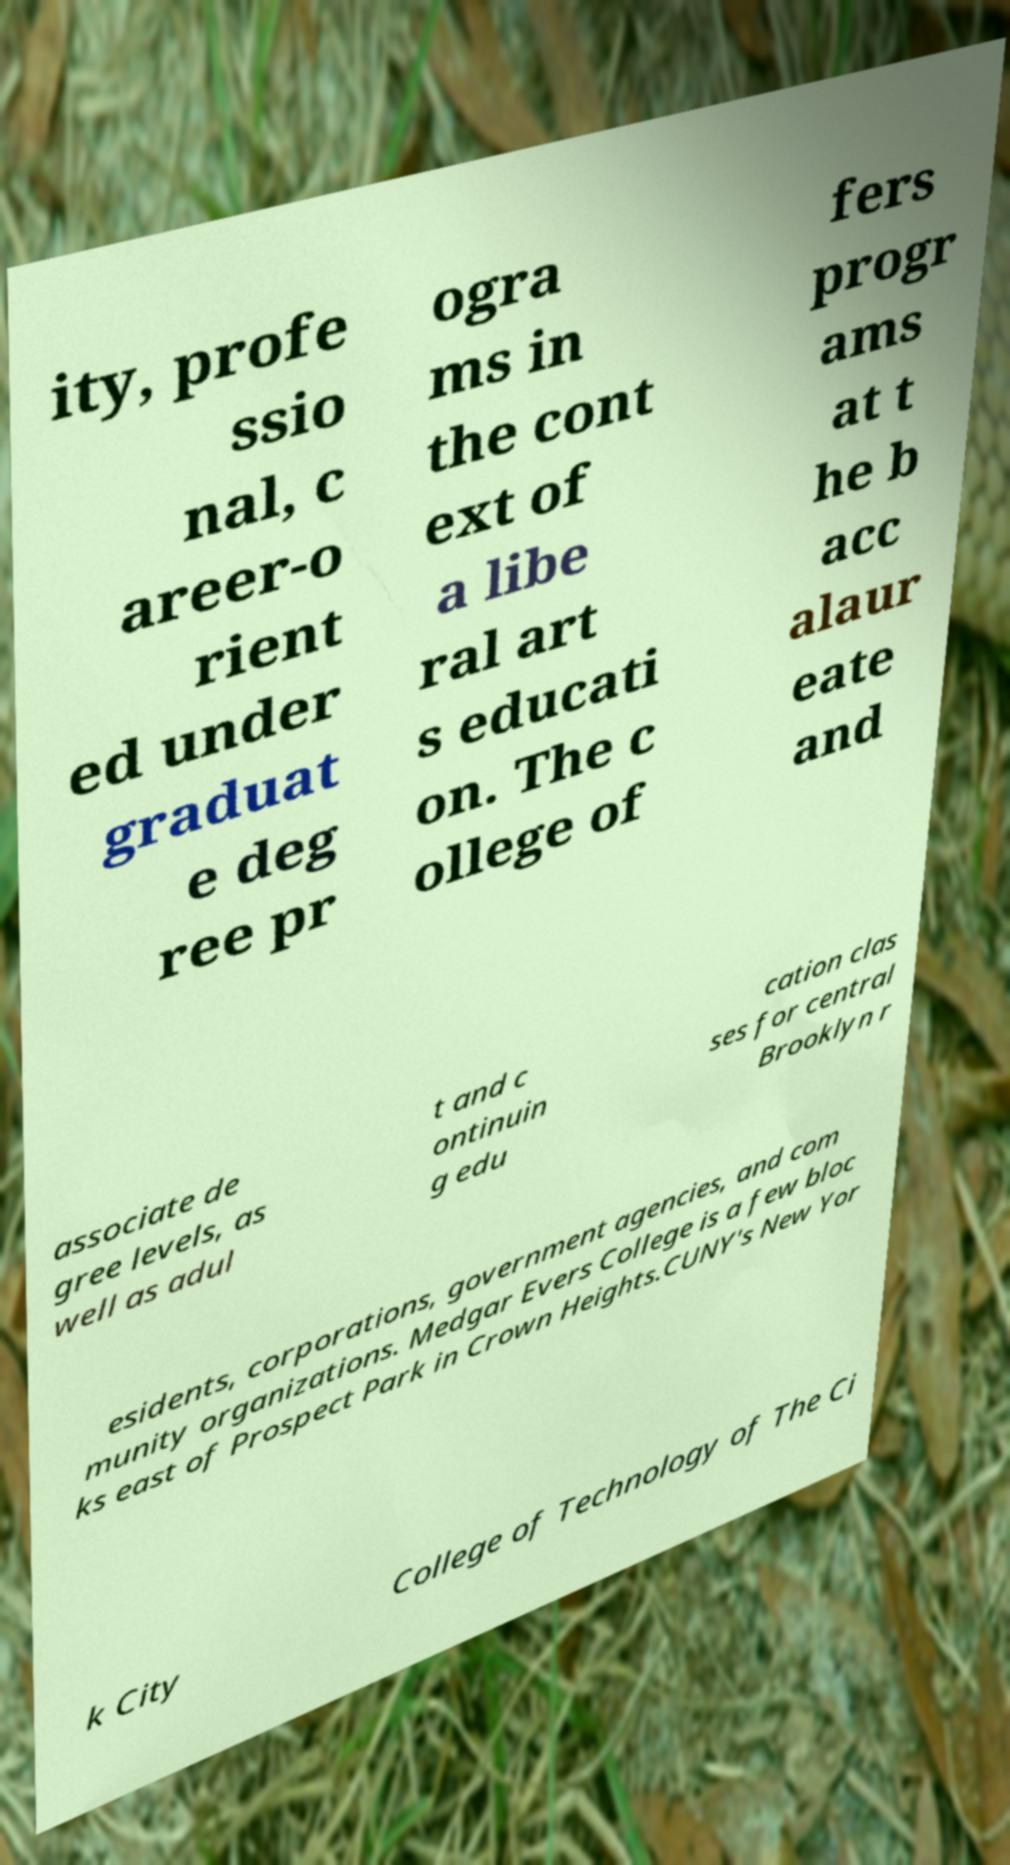Please identify and transcribe the text found in this image. ity, profe ssio nal, c areer-o rient ed under graduat e deg ree pr ogra ms in the cont ext of a libe ral art s educati on. The c ollege of fers progr ams at t he b acc alaur eate and associate de gree levels, as well as adul t and c ontinuin g edu cation clas ses for central Brooklyn r esidents, corporations, government agencies, and com munity organizations. Medgar Evers College is a few bloc ks east of Prospect Park in Crown Heights.CUNY's New Yor k City College of Technology of The Ci 